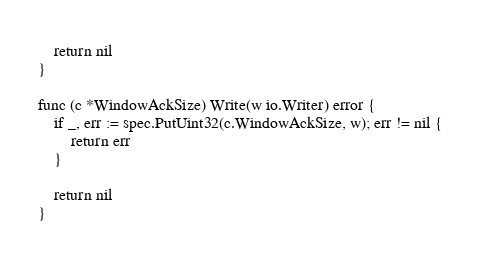<code> <loc_0><loc_0><loc_500><loc_500><_Go_>	return nil
}

func (c *WindowAckSize) Write(w io.Writer) error {
	if _, err := spec.PutUint32(c.WindowAckSize, w); err != nil {
		return err
	}

	return nil
}
</code> 